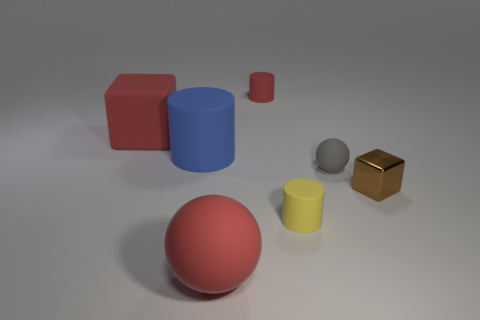Do the rubber cube and the large ball have the same color?
Offer a terse response. Yes. There is a large thing that is the same shape as the tiny metal object; what color is it?
Offer a very short reply. Red. What number of cubes are the same color as the large ball?
Your answer should be compact. 1. What is the material of the small block?
Ensure brevity in your answer.  Metal. What number of rubber objects are either small brown things or gray cubes?
Offer a terse response. 0. There is a small object that is the same color as the matte block; what is its material?
Offer a very short reply. Rubber. Is the number of gray matte objects that are on the left side of the matte cube less than the number of spheres in front of the tiny yellow matte thing?
Your answer should be compact. Yes. What number of objects are large red matte blocks or objects that are right of the gray ball?
Your answer should be very brief. 2. There is a block that is the same size as the yellow cylinder; what is its material?
Provide a succinct answer. Metal. Is the material of the small sphere the same as the brown block?
Your response must be concise. No. 